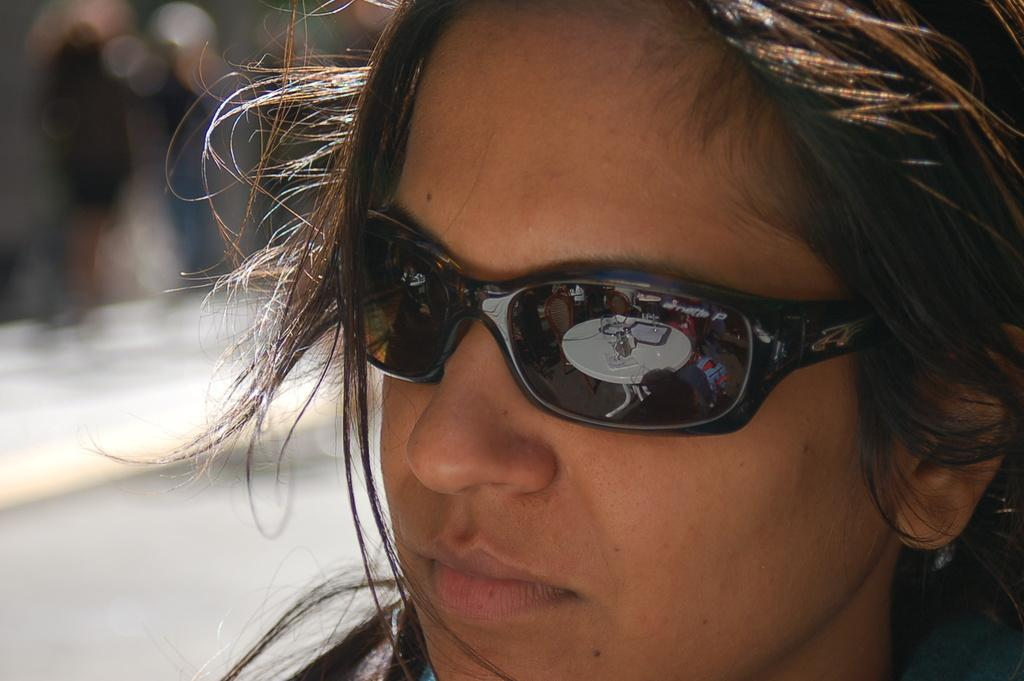Who or what is present in the image? There is a person in the image. What is the person wearing that is visible in the image? The person is wearing goggles. What can be seen through the goggles? The goggles show a white color table. What is on the table? There are objects on the table. How would you describe the background of the image? The background of the image is blurred. How many rings are visible on the table in the image? There is no mention of rings in the image, so it is impossible to determine their presence or quantity. 